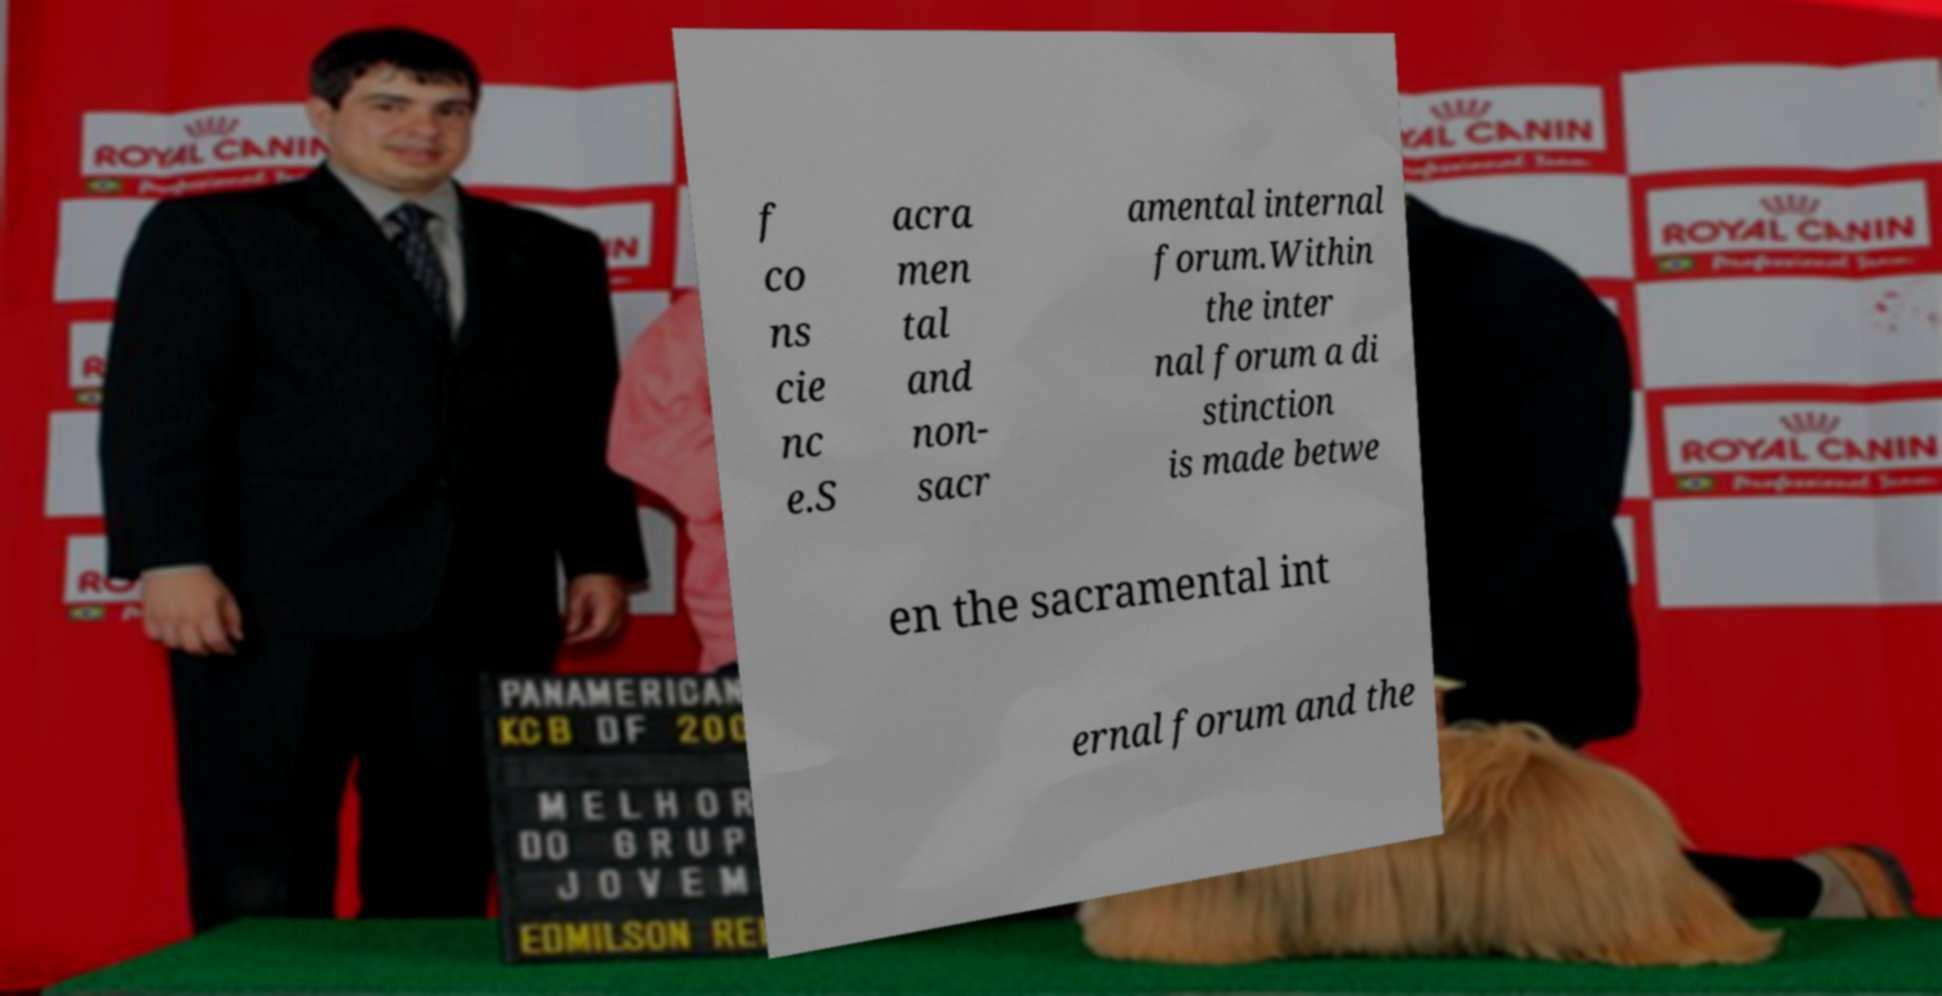Can you read and provide the text displayed in the image?This photo seems to have some interesting text. Can you extract and type it out for me? f co ns cie nc e.S acra men tal and non- sacr amental internal forum.Within the inter nal forum a di stinction is made betwe en the sacramental int ernal forum and the 